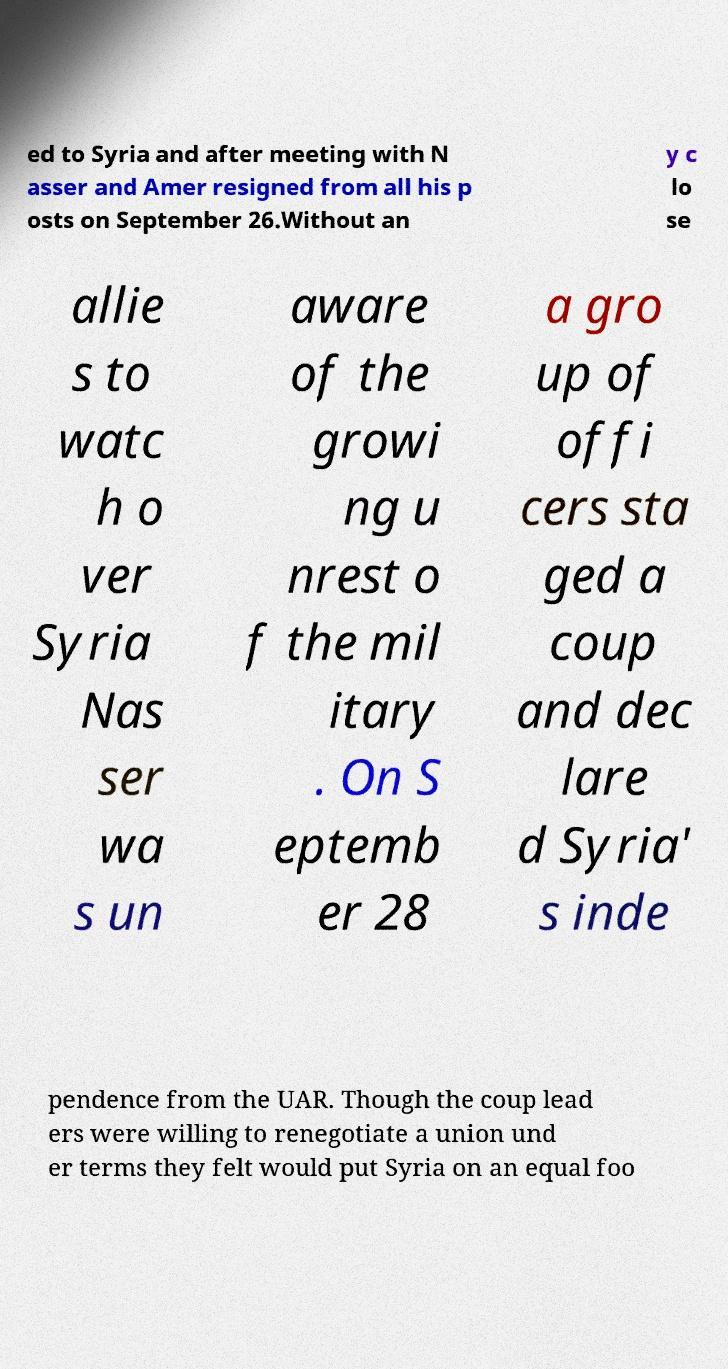Could you extract and type out the text from this image? ed to Syria and after meeting with N asser and Amer resigned from all his p osts on September 26.Without an y c lo se allie s to watc h o ver Syria Nas ser wa s un aware of the growi ng u nrest o f the mil itary . On S eptemb er 28 a gro up of offi cers sta ged a coup and dec lare d Syria' s inde pendence from the UAR. Though the coup lead ers were willing to renegotiate a union und er terms they felt would put Syria on an equal foo 